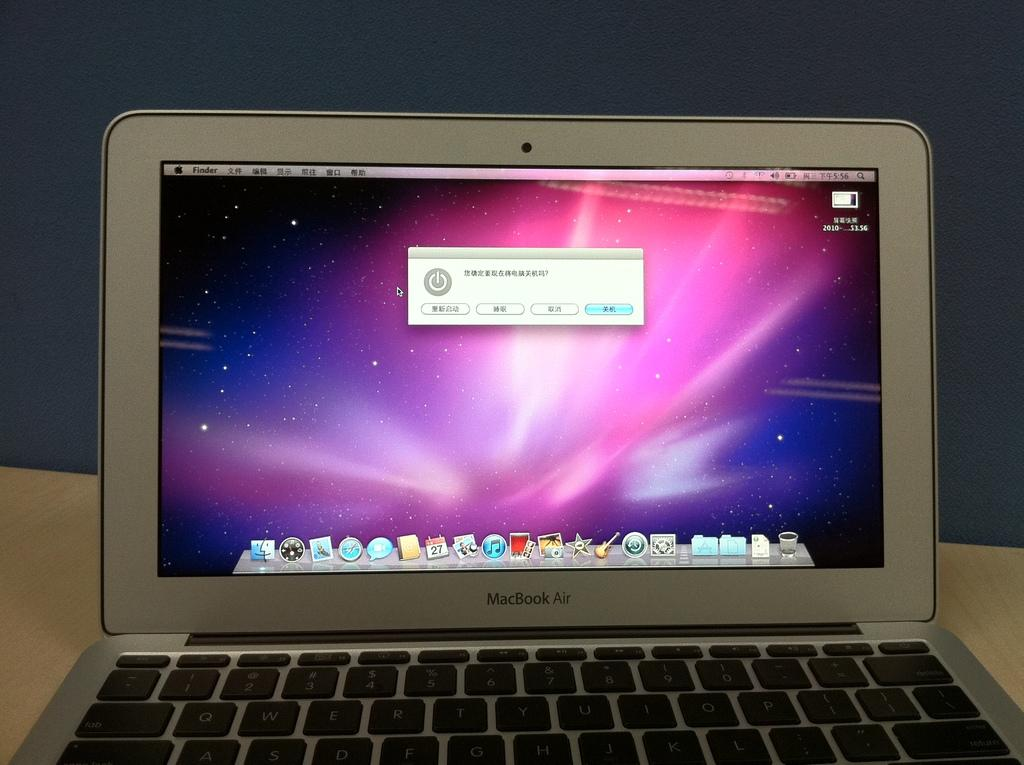<image>
Render a clear and concise summary of the photo. A MacBook Air computer that is open to the main screen 